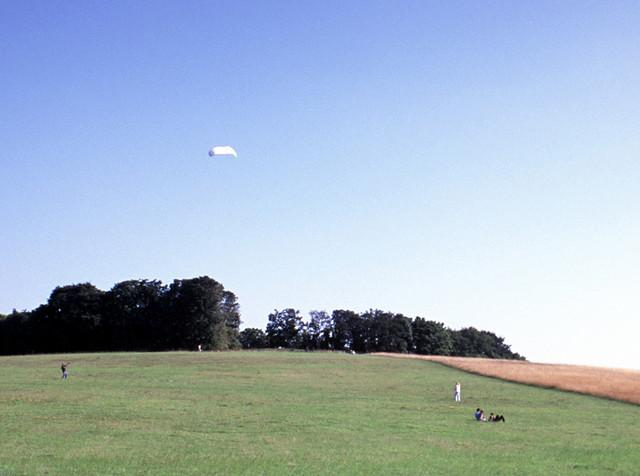What type of location is being visited?

Choices:
A) forest
B) swamp
C) ocean
D) field field 